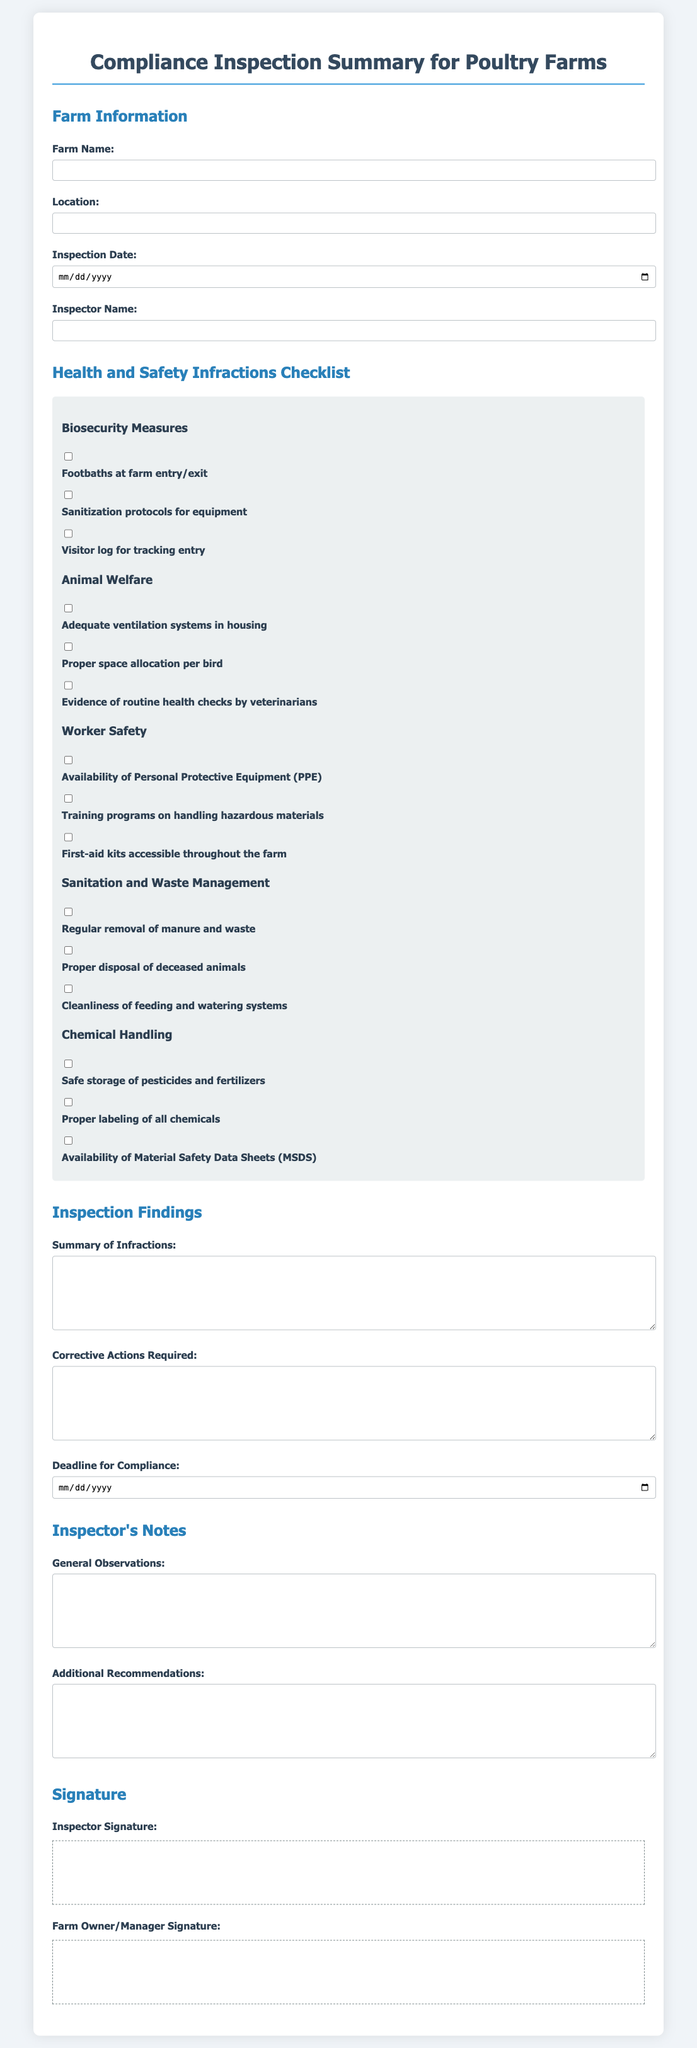what is the farm name? The farm name is a specific identifier provided in the document, which can be filled out in the form.
Answer: Farm Name: what is the location of the farm? The location of the farm is another specific detail that must be specified in the document.
Answer: Location: what is the date of the inspection? The inspection date is provided in a date input field and is a key detail for the inspection report.
Answer: Inspection Date: who conducted the inspection? The inspector's name is recorded in the document, indicating who performed the compliance inspection.
Answer: Inspector Name: what are the biosecurity measures included in the checklist? The checklist contains specific biosecurity measures that need to be evaluated during the inspection, making it essential information.
Answer: Footbaths, Sanitization protocols, Visitor log how many categories of health and safety infractions are there? The document organizes health and safety infractions into several categories, which must be counted for an understanding of compliance areas.
Answer: 4 is there a deadline for compliance? A compliance deadline is specified in the document, which indicates how much time the farm has to correct any infractions.
Answer: Compliance Deadline: what type of signature is required from the inspector? The document specifies different signatures needed, highlighting the importance of verification from both parties involved.
Answer: Inspector Signature what is required for proper chemical handling? The checklist includes items that relate to chemical handling, showcasing necessary safety protocols for these substances.
Answer: Safe storage, Proper labeling, Availability of MSDS what is a corrective action? The document features a section for corrective actions, which are essential for ensuring compliance after infractions are noted.
Answer: Corrective Actions Required: 